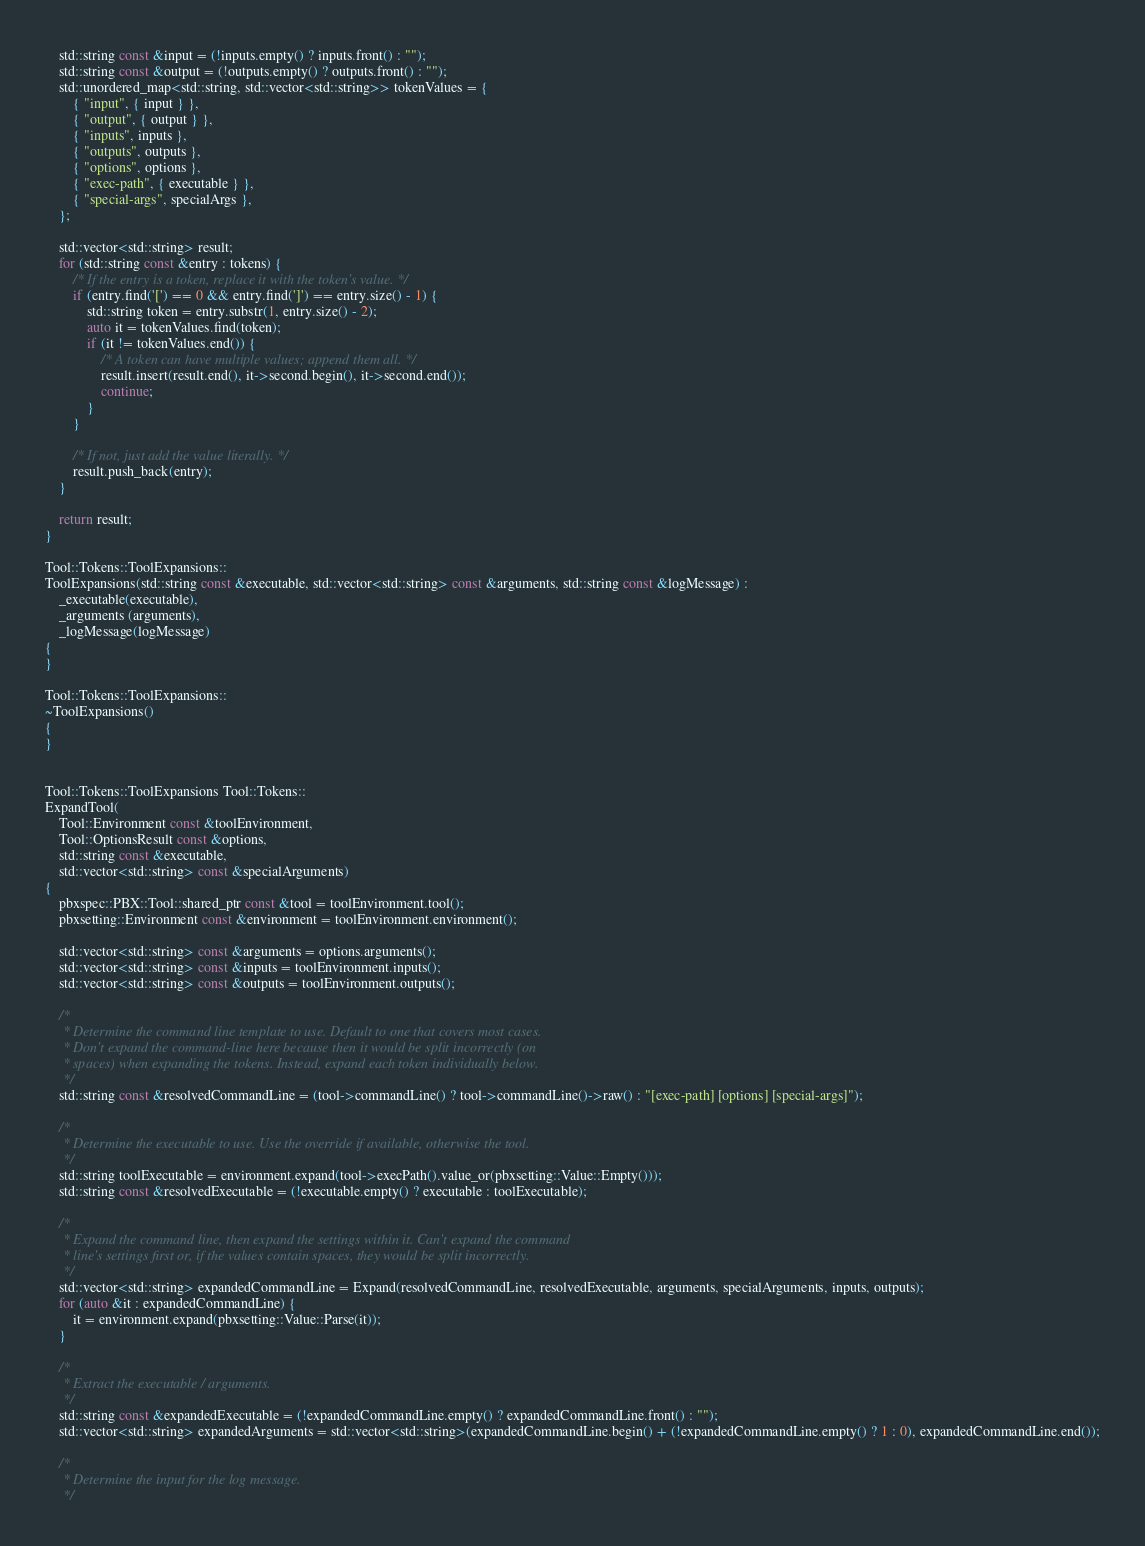Convert code to text. <code><loc_0><loc_0><loc_500><loc_500><_C++_>    std::string const &input = (!inputs.empty() ? inputs.front() : "");
    std::string const &output = (!outputs.empty() ? outputs.front() : "");
    std::unordered_map<std::string, std::vector<std::string>> tokenValues = {
        { "input", { input } },
        { "output", { output } },
        { "inputs", inputs },
        { "outputs", outputs },
        { "options", options },
        { "exec-path", { executable } },
        { "special-args", specialArgs },
    };

    std::vector<std::string> result;
    for (std::string const &entry : tokens) {
        /* If the entry is a token, replace it with the token's value. */
        if (entry.find('[') == 0 && entry.find(']') == entry.size() - 1) {
            std::string token = entry.substr(1, entry.size() - 2);
            auto it = tokenValues.find(token);
            if (it != tokenValues.end()) {
                /* A token can have multiple values; append them all. */
                result.insert(result.end(), it->second.begin(), it->second.end());
                continue;
            }
        }

        /* If not, just add the value literally. */
        result.push_back(entry);
    }

    return result;
}

Tool::Tokens::ToolExpansions::
ToolExpansions(std::string const &executable, std::vector<std::string> const &arguments, std::string const &logMessage) :
    _executable(executable),
    _arguments (arguments),
    _logMessage(logMessage)
{
}

Tool::Tokens::ToolExpansions::
~ToolExpansions()
{
}


Tool::Tokens::ToolExpansions Tool::Tokens::
ExpandTool(
    Tool::Environment const &toolEnvironment,
    Tool::OptionsResult const &options,
    std::string const &executable,
    std::vector<std::string> const &specialArguments)
{
    pbxspec::PBX::Tool::shared_ptr const &tool = toolEnvironment.tool();
    pbxsetting::Environment const &environment = toolEnvironment.environment();

    std::vector<std::string> const &arguments = options.arguments();
    std::vector<std::string> const &inputs = toolEnvironment.inputs();
    std::vector<std::string> const &outputs = toolEnvironment.outputs();

    /*
     * Determine the command line template to use. Default to one that covers most cases.
     * Don't expand the command-line here because then it would be split incorrectly (on
     * spaces) when expanding the tokens. Instead, expand each token individually below.
     */
    std::string const &resolvedCommandLine = (tool->commandLine() ? tool->commandLine()->raw() : "[exec-path] [options] [special-args]");

    /*
     * Determine the executable to use. Use the override if available, otherwise the tool.
     */
    std::string toolExecutable = environment.expand(tool->execPath().value_or(pbxsetting::Value::Empty()));
    std::string const &resolvedExecutable = (!executable.empty() ? executable : toolExecutable);

    /*
     * Expand the command line, then expand the settings within it. Can't expand the command
     * line's settings first or, if the values contain spaces, they would be split incorrectly.
     */
    std::vector<std::string> expandedCommandLine = Expand(resolvedCommandLine, resolvedExecutable, arguments, specialArguments, inputs, outputs);
    for (auto &it : expandedCommandLine) {
        it = environment.expand(pbxsetting::Value::Parse(it));
    }

    /*
     * Extract the executable / arguments.
     */
    std::string const &expandedExecutable = (!expandedCommandLine.empty() ? expandedCommandLine.front() : "");
    std::vector<std::string> expandedArguments = std::vector<std::string>(expandedCommandLine.begin() + (!expandedCommandLine.empty() ? 1 : 0), expandedCommandLine.end());

    /*
     * Determine the input for the log message.
     */</code> 